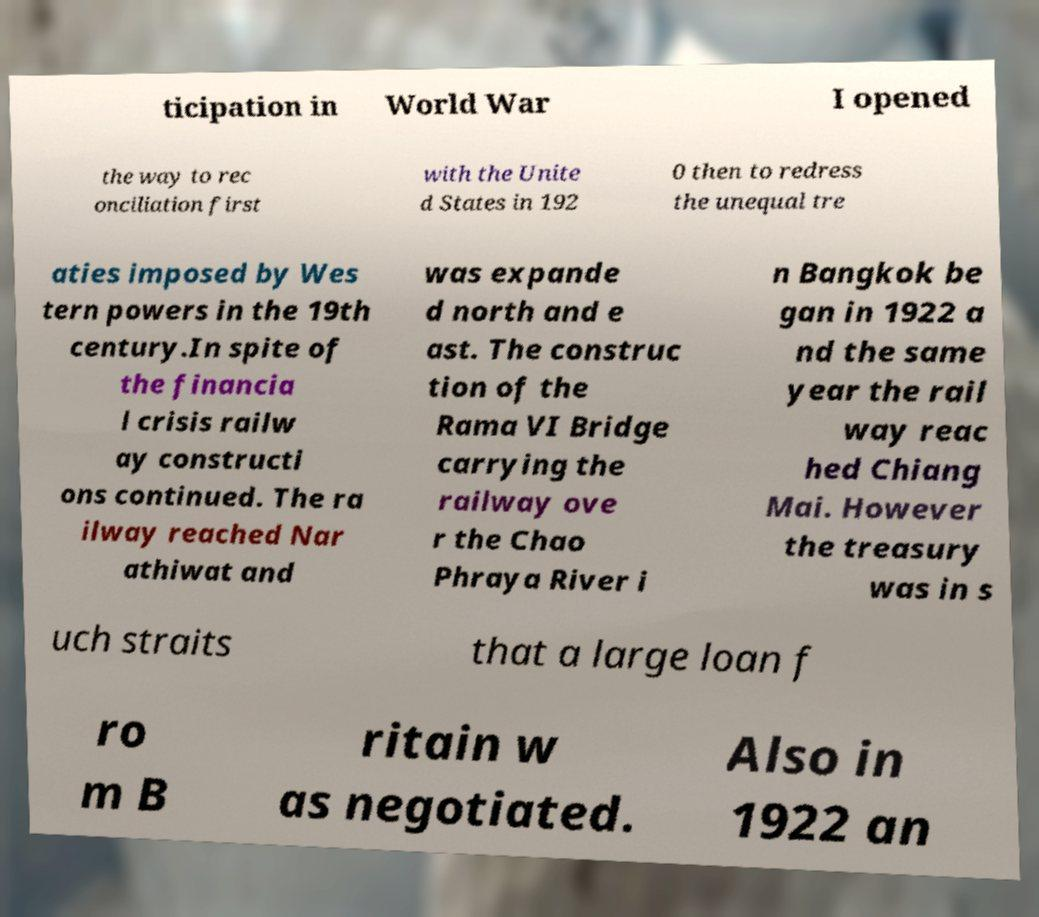Could you assist in decoding the text presented in this image and type it out clearly? ticipation in World War I opened the way to rec onciliation first with the Unite d States in 192 0 then to redress the unequal tre aties imposed by Wes tern powers in the 19th century.In spite of the financia l crisis railw ay constructi ons continued. The ra ilway reached Nar athiwat and was expande d north and e ast. The construc tion of the Rama VI Bridge carrying the railway ove r the Chao Phraya River i n Bangkok be gan in 1922 a nd the same year the rail way reac hed Chiang Mai. However the treasury was in s uch straits that a large loan f ro m B ritain w as negotiated. Also in 1922 an 